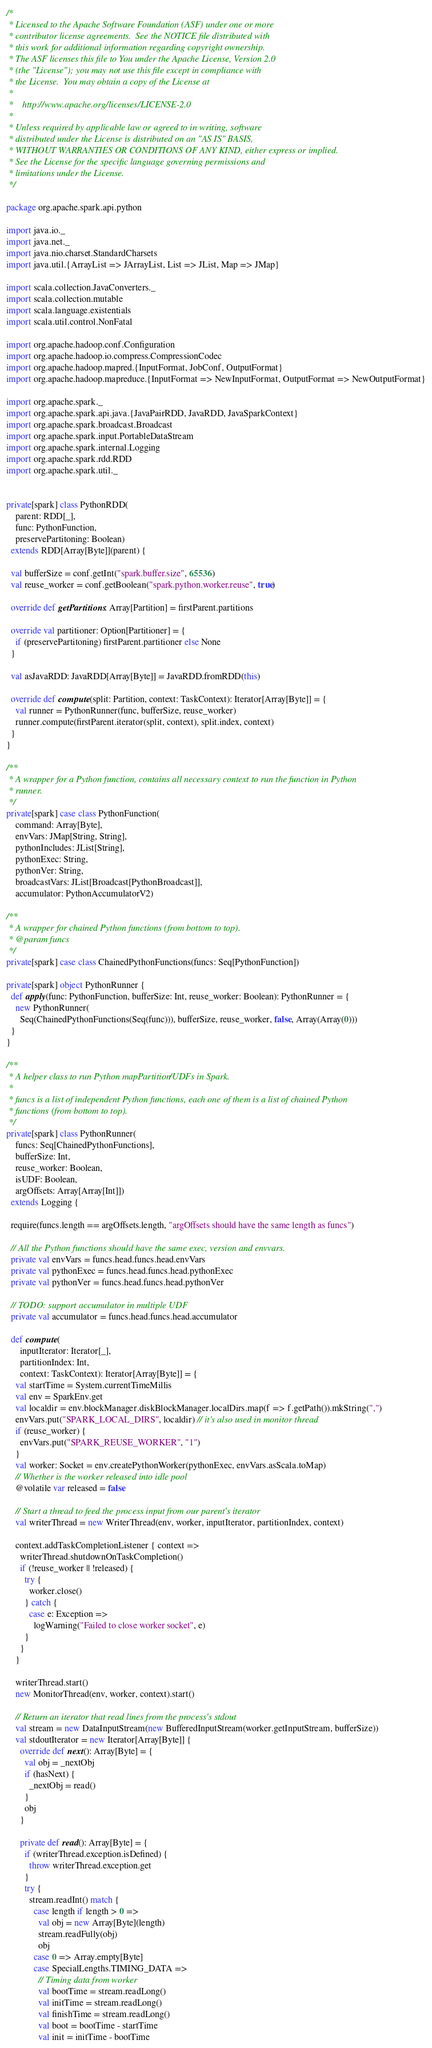<code> <loc_0><loc_0><loc_500><loc_500><_Scala_>/*
 * Licensed to the Apache Software Foundation (ASF) under one or more
 * contributor license agreements.  See the NOTICE file distributed with
 * this work for additional information regarding copyright ownership.
 * The ASF licenses this file to You under the Apache License, Version 2.0
 * (the "License"); you may not use this file except in compliance with
 * the License.  You may obtain a copy of the License at
 *
 *    http://www.apache.org/licenses/LICENSE-2.0
 *
 * Unless required by applicable law or agreed to in writing, software
 * distributed under the License is distributed on an "AS IS" BASIS,
 * WITHOUT WARRANTIES OR CONDITIONS OF ANY KIND, either express or implied.
 * See the License for the specific language governing permissions and
 * limitations under the License.
 */

package org.apache.spark.api.python

import java.io._
import java.net._
import java.nio.charset.StandardCharsets
import java.util.{ArrayList => JArrayList, List => JList, Map => JMap}

import scala.collection.JavaConverters._
import scala.collection.mutable
import scala.language.existentials
import scala.util.control.NonFatal

import org.apache.hadoop.conf.Configuration
import org.apache.hadoop.io.compress.CompressionCodec
import org.apache.hadoop.mapred.{InputFormat, JobConf, OutputFormat}
import org.apache.hadoop.mapreduce.{InputFormat => NewInputFormat, OutputFormat => NewOutputFormat}

import org.apache.spark._
import org.apache.spark.api.java.{JavaPairRDD, JavaRDD, JavaSparkContext}
import org.apache.spark.broadcast.Broadcast
import org.apache.spark.input.PortableDataStream
import org.apache.spark.internal.Logging
import org.apache.spark.rdd.RDD
import org.apache.spark.util._


private[spark] class PythonRDD(
    parent: RDD[_],
    func: PythonFunction,
    preservePartitoning: Boolean)
  extends RDD[Array[Byte]](parent) {

  val bufferSize = conf.getInt("spark.buffer.size", 65536)
  val reuse_worker = conf.getBoolean("spark.python.worker.reuse", true)

  override def getPartitions: Array[Partition] = firstParent.partitions

  override val partitioner: Option[Partitioner] = {
    if (preservePartitoning) firstParent.partitioner else None
  }

  val asJavaRDD: JavaRDD[Array[Byte]] = JavaRDD.fromRDD(this)

  override def compute(split: Partition, context: TaskContext): Iterator[Array[Byte]] = {
    val runner = PythonRunner(func, bufferSize, reuse_worker)
    runner.compute(firstParent.iterator(split, context), split.index, context)
  }
}

/**
 * A wrapper for a Python function, contains all necessary context to run the function in Python
 * runner.
 */
private[spark] case class PythonFunction(
    command: Array[Byte],
    envVars: JMap[String, String],
    pythonIncludes: JList[String],
    pythonExec: String,
    pythonVer: String,
    broadcastVars: JList[Broadcast[PythonBroadcast]],
    accumulator: PythonAccumulatorV2)

/**
 * A wrapper for chained Python functions (from bottom to top).
 * @param funcs
 */
private[spark] case class ChainedPythonFunctions(funcs: Seq[PythonFunction])

private[spark] object PythonRunner {
  def apply(func: PythonFunction, bufferSize: Int, reuse_worker: Boolean): PythonRunner = {
    new PythonRunner(
      Seq(ChainedPythonFunctions(Seq(func))), bufferSize, reuse_worker, false, Array(Array(0)))
  }
}

/**
 * A helper class to run Python mapPartition/UDFs in Spark.
 *
 * funcs is a list of independent Python functions, each one of them is a list of chained Python
 * functions (from bottom to top).
 */
private[spark] class PythonRunner(
    funcs: Seq[ChainedPythonFunctions],
    bufferSize: Int,
    reuse_worker: Boolean,
    isUDF: Boolean,
    argOffsets: Array[Array[Int]])
  extends Logging {

  require(funcs.length == argOffsets.length, "argOffsets should have the same length as funcs")

  // All the Python functions should have the same exec, version and envvars.
  private val envVars = funcs.head.funcs.head.envVars
  private val pythonExec = funcs.head.funcs.head.pythonExec
  private val pythonVer = funcs.head.funcs.head.pythonVer

  // TODO: support accumulator in multiple UDF
  private val accumulator = funcs.head.funcs.head.accumulator

  def compute(
      inputIterator: Iterator[_],
      partitionIndex: Int,
      context: TaskContext): Iterator[Array[Byte]] = {
    val startTime = System.currentTimeMillis
    val env = SparkEnv.get
    val localdir = env.blockManager.diskBlockManager.localDirs.map(f => f.getPath()).mkString(",")
    envVars.put("SPARK_LOCAL_DIRS", localdir) // it's also used in monitor thread
    if (reuse_worker) {
      envVars.put("SPARK_REUSE_WORKER", "1")
    }
    val worker: Socket = env.createPythonWorker(pythonExec, envVars.asScala.toMap)
    // Whether is the worker released into idle pool
    @volatile var released = false

    // Start a thread to feed the process input from our parent's iterator
    val writerThread = new WriterThread(env, worker, inputIterator, partitionIndex, context)

    context.addTaskCompletionListener { context =>
      writerThread.shutdownOnTaskCompletion()
      if (!reuse_worker || !released) {
        try {
          worker.close()
        } catch {
          case e: Exception =>
            logWarning("Failed to close worker socket", e)
        }
      }
    }

    writerThread.start()
    new MonitorThread(env, worker, context).start()

    // Return an iterator that read lines from the process's stdout
    val stream = new DataInputStream(new BufferedInputStream(worker.getInputStream, bufferSize))
    val stdoutIterator = new Iterator[Array[Byte]] {
      override def next(): Array[Byte] = {
        val obj = _nextObj
        if (hasNext) {
          _nextObj = read()
        }
        obj
      }

      private def read(): Array[Byte] = {
        if (writerThread.exception.isDefined) {
          throw writerThread.exception.get
        }
        try {
          stream.readInt() match {
            case length if length > 0 =>
              val obj = new Array[Byte](length)
              stream.readFully(obj)
              obj
            case 0 => Array.empty[Byte]
            case SpecialLengths.TIMING_DATA =>
              // Timing data from worker
              val bootTime = stream.readLong()
              val initTime = stream.readLong()
              val finishTime = stream.readLong()
              val boot = bootTime - startTime
              val init = initTime - bootTime</code> 